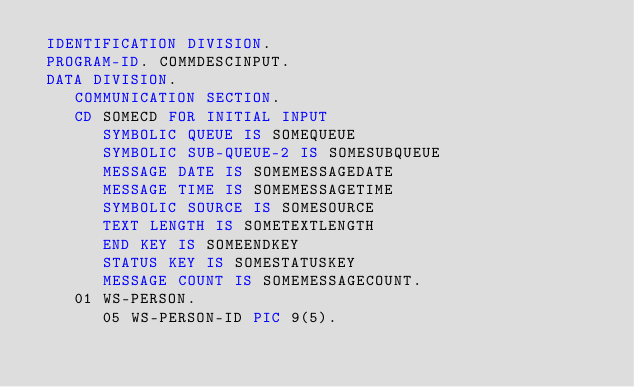Convert code to text. <code><loc_0><loc_0><loc_500><loc_500><_COBOL_> IDENTIFICATION DIVISION.
 PROGRAM-ID. COMMDESCINPUT.
 DATA DIVISION.
    COMMUNICATION SECTION.
    CD SOMECD FOR INITIAL INPUT
       SYMBOLIC QUEUE IS SOMEQUEUE
       SYMBOLIC SUB-QUEUE-2 IS SOMESUBQUEUE
       MESSAGE DATE IS SOMEMESSAGEDATE
       MESSAGE TIME IS SOMEMESSAGETIME
       SYMBOLIC SOURCE IS SOMESOURCE
       TEXT LENGTH IS SOMETEXTLENGTH
       END KEY IS SOMEENDKEY
       STATUS KEY IS SOMESTATUSKEY
       MESSAGE COUNT IS SOMEMESSAGECOUNT.
    01 WS-PERSON.
       05 WS-PERSON-ID PIC 9(5).</code> 